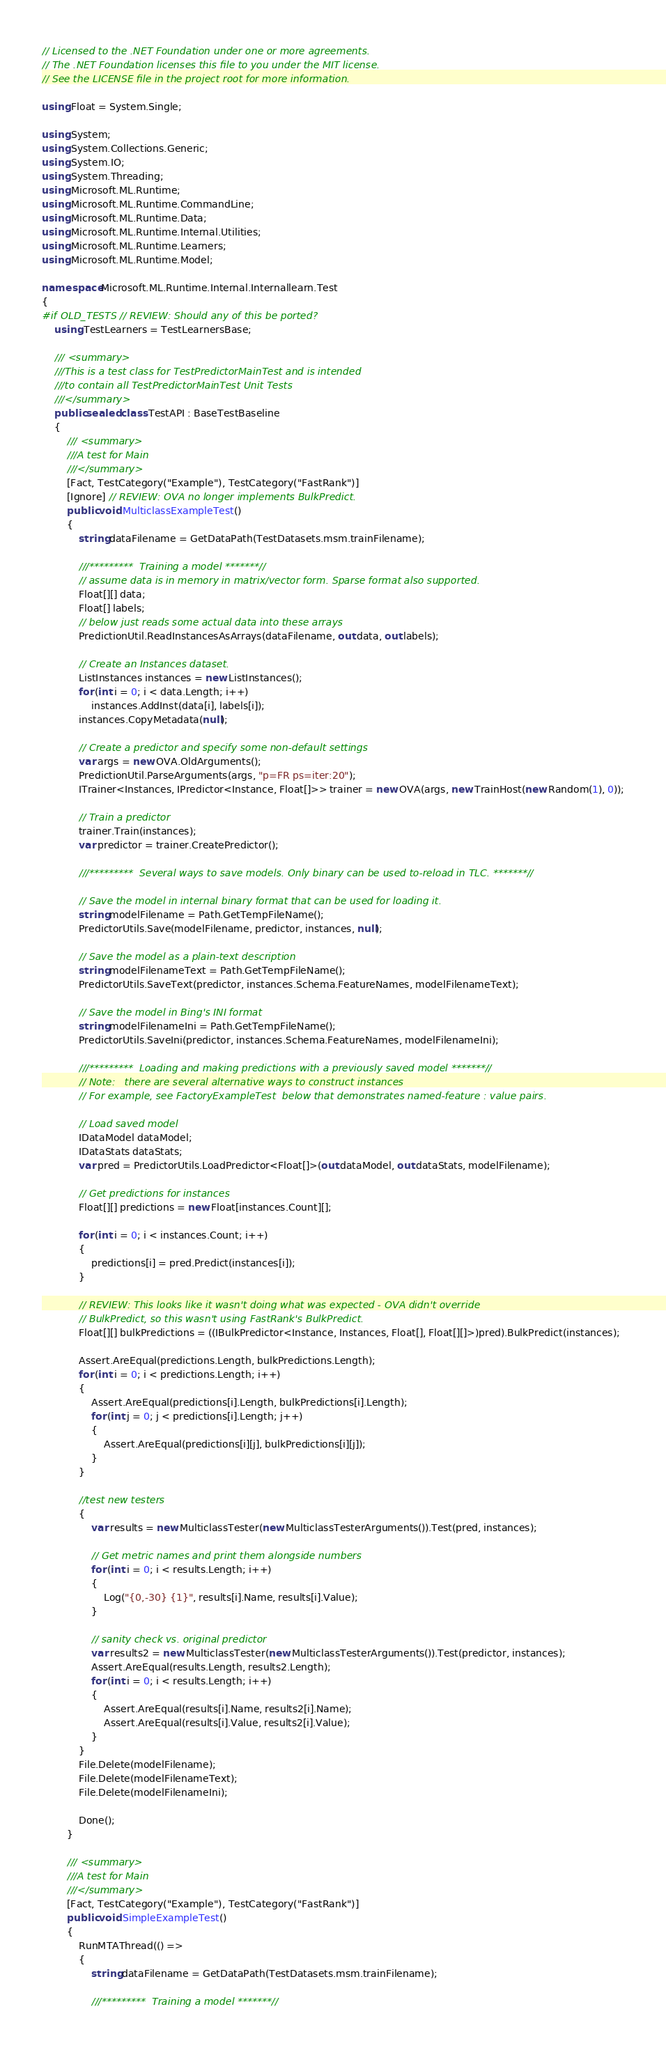<code> <loc_0><loc_0><loc_500><loc_500><_C#_>// Licensed to the .NET Foundation under one or more agreements.
// The .NET Foundation licenses this file to you under the MIT license.
// See the LICENSE file in the project root for more information.

using Float = System.Single;

using System;
using System.Collections.Generic;
using System.IO;
using System.Threading;
using Microsoft.ML.Runtime;
using Microsoft.ML.Runtime.CommandLine;
using Microsoft.ML.Runtime.Data;
using Microsoft.ML.Runtime.Internal.Utilities;
using Microsoft.ML.Runtime.Learners;
using Microsoft.ML.Runtime.Model;

namespace Microsoft.ML.Runtime.Internal.Internallearn.Test
{
#if OLD_TESTS // REVIEW: Should any of this be ported?
    using TestLearners = TestLearnersBase;

    /// <summary>
    ///This is a test class for TestPredictorMainTest and is intended
    ///to contain all TestPredictorMainTest Unit Tests
    ///</summary>
    public sealed class TestAPI : BaseTestBaseline
    {
        /// <summary>
        ///A test for Main
        ///</summary>
        [Fact, TestCategory("Example"), TestCategory("FastRank")]
        [Ignore] // REVIEW: OVA no longer implements BulkPredict.
        public void MulticlassExampleTest()
        {
            string dataFilename = GetDataPath(TestDatasets.msm.trainFilename);

            ///*********  Training a model *******//
            // assume data is in memory in matrix/vector form. Sparse format also supported.
            Float[][] data;
            Float[] labels;
            // below just reads some actual data into these arrays
            PredictionUtil.ReadInstancesAsArrays(dataFilename, out data, out labels);

            // Create an Instances dataset.
            ListInstances instances = new ListInstances();
            for (int i = 0; i < data.Length; i++)
                instances.AddInst(data[i], labels[i]);
            instances.CopyMetadata(null);

            // Create a predictor and specify some non-default settings
            var args = new OVA.OldArguments();
            PredictionUtil.ParseArguments(args, "p=FR ps=iter:20");
            ITrainer<Instances, IPredictor<Instance, Float[]>> trainer = new OVA(args, new TrainHost(new Random(1), 0));

            // Train a predictor
            trainer.Train(instances);
            var predictor = trainer.CreatePredictor();

            ///*********  Several ways to save models. Only binary can be used to-reload in TLC. *******//

            // Save the model in internal binary format that can be used for loading it.
            string modelFilename = Path.GetTempFileName();
            PredictorUtils.Save(modelFilename, predictor, instances, null);

            // Save the model as a plain-text description
            string modelFilenameText = Path.GetTempFileName();
            PredictorUtils.SaveText(predictor, instances.Schema.FeatureNames, modelFilenameText);

            // Save the model in Bing's INI format
            string modelFilenameIni = Path.GetTempFileName();
            PredictorUtils.SaveIni(predictor, instances.Schema.FeatureNames, modelFilenameIni);

            ///*********  Loading and making predictions with a previously saved model *******//
            // Note:   there are several alternative ways to construct instances
            // For example, see FactoryExampleTest  below that demonstrates named-feature : value pairs.

            // Load saved model
            IDataModel dataModel;
            IDataStats dataStats;
            var pred = PredictorUtils.LoadPredictor<Float[]>(out dataModel, out dataStats, modelFilename);

            // Get predictions for instances
            Float[][] predictions = new Float[instances.Count][];

            for (int i = 0; i < instances.Count; i++)
            {
                predictions[i] = pred.Predict(instances[i]);
            }

            // REVIEW: This looks like it wasn't doing what was expected - OVA didn't override
            // BulkPredict, so this wasn't using FastRank's BulkPredict.
            Float[][] bulkPredictions = ((IBulkPredictor<Instance, Instances, Float[], Float[][]>)pred).BulkPredict(instances);

            Assert.AreEqual(predictions.Length, bulkPredictions.Length);
            for (int i = 0; i < predictions.Length; i++)
            {
                Assert.AreEqual(predictions[i].Length, bulkPredictions[i].Length);
                for (int j = 0; j < predictions[i].Length; j++)
                {
                    Assert.AreEqual(predictions[i][j], bulkPredictions[i][j]);
                }
            }

            //test new testers
            {
                var results = new MulticlassTester(new MulticlassTesterArguments()).Test(pred, instances);

                // Get metric names and print them alongside numbers
                for (int i = 0; i < results.Length; i++)
                {
                    Log("{0,-30} {1}", results[i].Name, results[i].Value);
                }

                // sanity check vs. original predictor
                var results2 = new MulticlassTester(new MulticlassTesterArguments()).Test(predictor, instances);
                Assert.AreEqual(results.Length, results2.Length);
                for (int i = 0; i < results.Length; i++)
                {
                    Assert.AreEqual(results[i].Name, results2[i].Name);
                    Assert.AreEqual(results[i].Value, results2[i].Value);
                }
            }
            File.Delete(modelFilename);
            File.Delete(modelFilenameText);
            File.Delete(modelFilenameIni);

            Done();
        }

        /// <summary>
        ///A test for Main
        ///</summary>
        [Fact, TestCategory("Example"), TestCategory("FastRank")]
        public void SimpleExampleTest()
        {
            RunMTAThread(() =>
            {
                string dataFilename = GetDataPath(TestDatasets.msm.trainFilename);

                ///*********  Training a model *******//</code> 